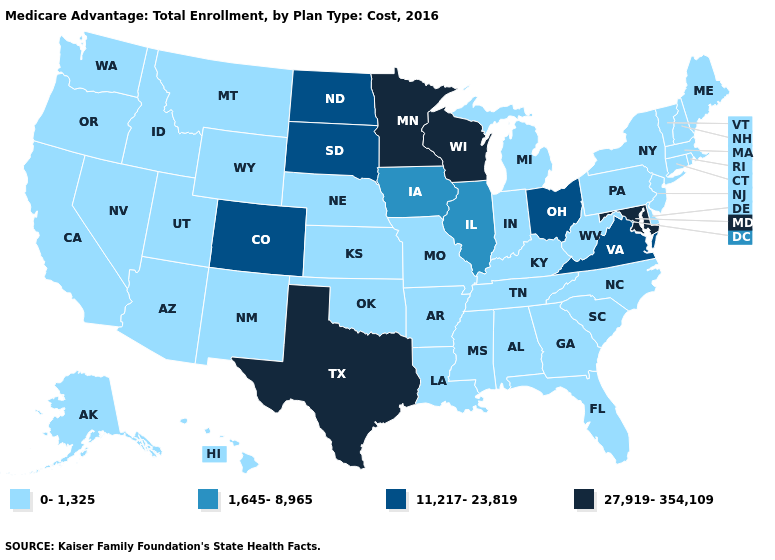What is the highest value in states that border Maryland?
Short answer required. 11,217-23,819. Among the states that border Vermont , which have the lowest value?
Answer briefly. Massachusetts, New Hampshire, New York. What is the lowest value in states that border Louisiana?
Answer briefly. 0-1,325. Name the states that have a value in the range 1,645-8,965?
Give a very brief answer. Iowa, Illinois. Does Wisconsin have the highest value in the USA?
Give a very brief answer. Yes. Does Texas have the same value as Nebraska?
Write a very short answer. No. Name the states that have a value in the range 1,645-8,965?
Short answer required. Iowa, Illinois. What is the value of Georgia?
Short answer required. 0-1,325. Name the states that have a value in the range 1,645-8,965?
Concise answer only. Iowa, Illinois. Name the states that have a value in the range 11,217-23,819?
Concise answer only. Colorado, North Dakota, Ohio, South Dakota, Virginia. What is the lowest value in the West?
Give a very brief answer. 0-1,325. What is the highest value in the Northeast ?
Keep it brief. 0-1,325. What is the value of Washington?
Keep it brief. 0-1,325. Does Montana have the lowest value in the USA?
Quick response, please. Yes. Name the states that have a value in the range 0-1,325?
Keep it brief. Alaska, Alabama, Arkansas, Arizona, California, Connecticut, Delaware, Florida, Georgia, Hawaii, Idaho, Indiana, Kansas, Kentucky, Louisiana, Massachusetts, Maine, Michigan, Missouri, Mississippi, Montana, North Carolina, Nebraska, New Hampshire, New Jersey, New Mexico, Nevada, New York, Oklahoma, Oregon, Pennsylvania, Rhode Island, South Carolina, Tennessee, Utah, Vermont, Washington, West Virginia, Wyoming. 